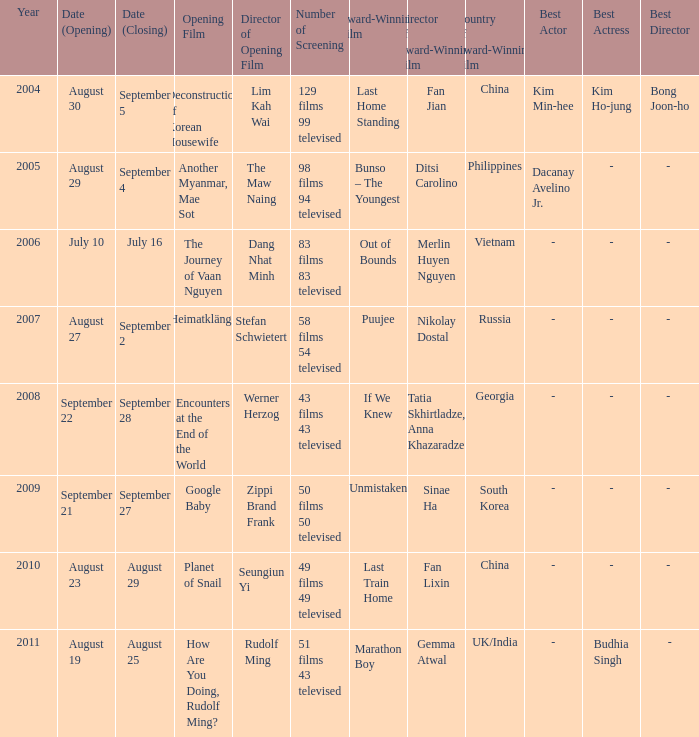On august 23, which film is set to be the opening feature? Planet of Snail. 